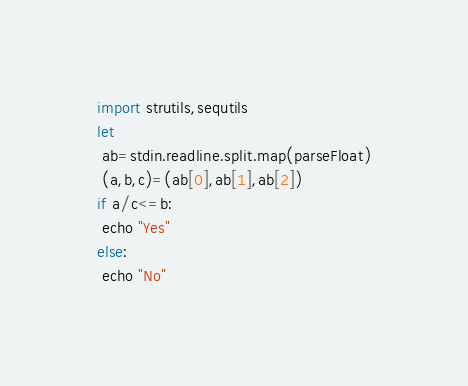Convert code to text. <code><loc_0><loc_0><loc_500><loc_500><_Nim_>import strutils,sequtils
let
 ab=stdin.readline.split.map(parseFloat)
 (a,b,c)=(ab[0],ab[1],ab[2])
if a/c<=b:
 echo "Yes"
else:
 echo "No"</code> 